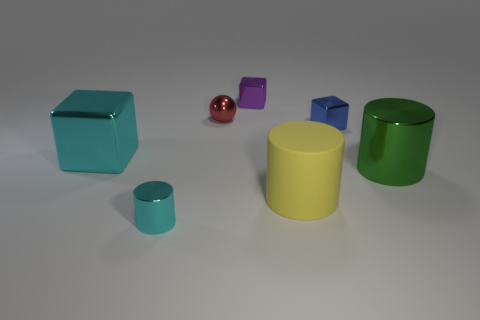What materials do these objects seem to be made of? The objects in the image appear to have a smooth, matte finish, suggesting they could be composed of plastic or a digitally rendered material. 